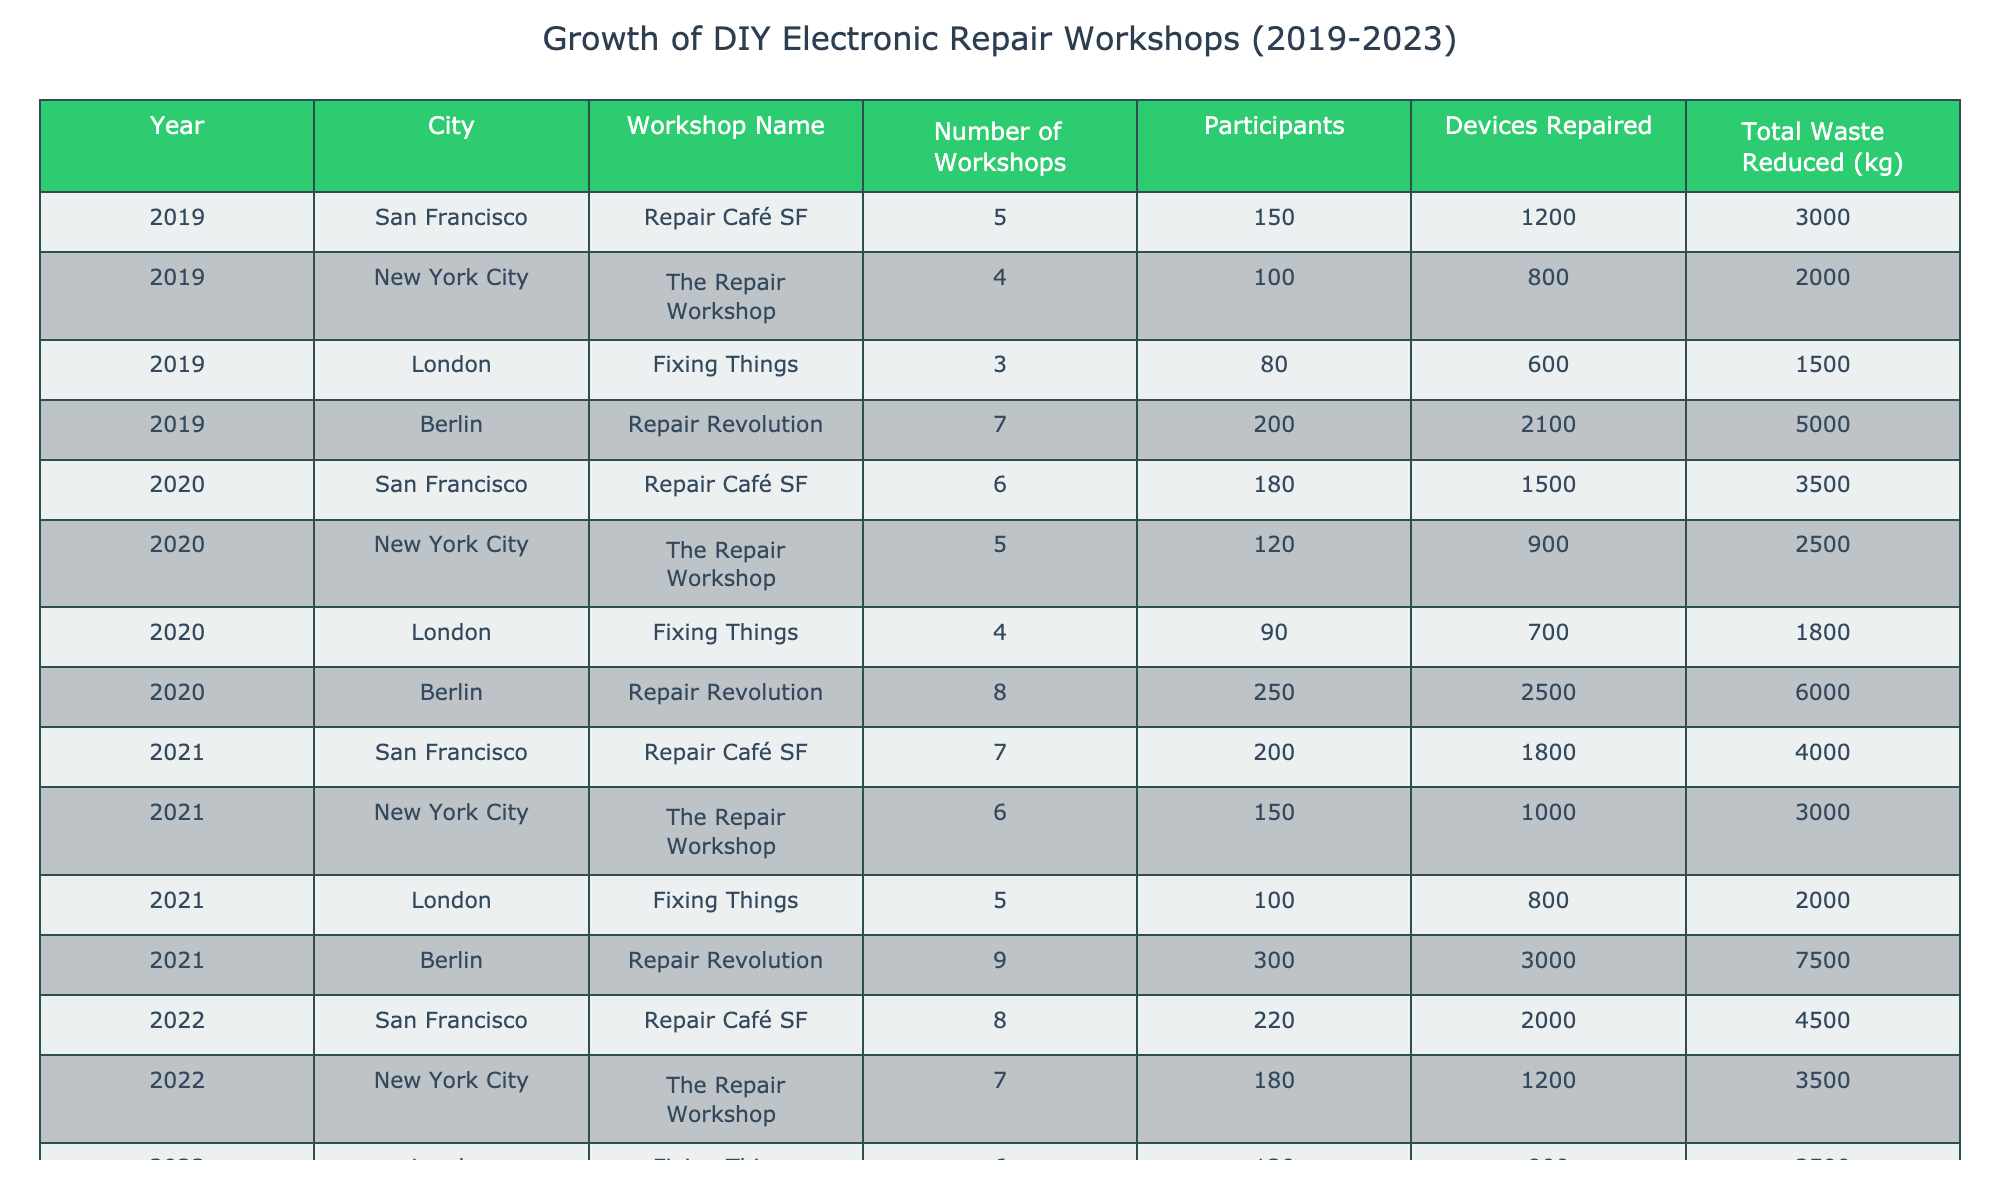What was the total waste reduced in Berlin in 2023? In 2023, the total waste reduced in Berlin was recorded as 9000 kg.
Answer: 9000 kg How many participants attended the workshops in New York City in 2022? In 2022, the number of participants in New York City was 180.
Answer: 180 What is the increase in the number of workshops in San Francisco from 2019 to 2023? In 2019, there were 5 workshops in San Francisco, and by 2023, this increased to 9 workshops. The increase is 9 - 5 = 4 workshops.
Answer: 4 workshops Which city had the highest number of devices repaired in 2021? In 2021, Berlin had the highest number of devices repaired at 3000.
Answer: Berlin What was the average number of workshops across all cities in 2020? The total number of workshops across those cities in 2020 is (6 + 5 + 4 + 8) = 23. There are 4 cities, so the average is 23 / 4 = 5.75 workshops.
Answer: 5.75 workshops Did the number of participants in London increase from 2020 to 2022? In 2020, London had 90 participants, and in 2022, the number increased to 120 participants, confirming an increase.
Answer: Yes How much total waste was reduced by all workshops combined in 2019? For 2019, the total waste reduced is the sum of all workshops: 3000 + 2000 + 1500 + 5000 = 11500 kg.
Answer: 11500 kg Which workshop in 2023 had the fewest participants and how many were there? In 2023, the Fixing Things workshop in London had the fewest participants with 150.
Answer: 150 What is the trend of devices repaired from 2019 to 2023 in Berlin? In Berlin, the devices repaired increased from 2100 in 2019 to 4000 in 2023. The trend shows that the number has consistently increased over the years.
Answer: Increasing How many more devices were repaired in San Francisco compared to New York City in 2022? In 2022, San Francisco repaired 2000 devices, while New York City repaired 1200 devices. The difference is 2000 - 1200 = 800 devices more in San Francisco.
Answer: 800 devices What percentage of total waste reduced in 2020 came from Berlin? In 2020, total waste from Berlin was 6000 kg out of a total of 2500 + 3500 + 1800 + 6000 = 17000 kg. The percentage is (6000 / 17000) * 100 ≈ 35.29%.
Answer: Approximately 35.29% 